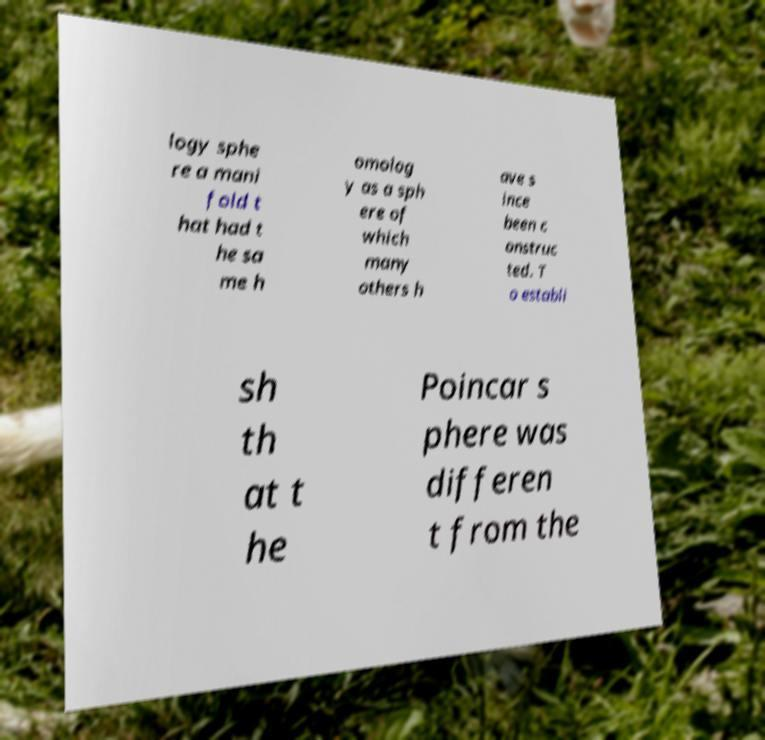Can you accurately transcribe the text from the provided image for me? logy sphe re a mani fold t hat had t he sa me h omolog y as a sph ere of which many others h ave s ince been c onstruc ted. T o establi sh th at t he Poincar s phere was differen t from the 